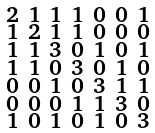<formula> <loc_0><loc_0><loc_500><loc_500>\begin{smallmatrix} 2 & 1 & 1 & 1 & 0 & 0 & 1 \\ 1 & 2 & 1 & 1 & 0 & 0 & 0 \\ 1 & 1 & 3 & 0 & 1 & 0 & 1 \\ 1 & 1 & 0 & 3 & 0 & 1 & 0 \\ 0 & 0 & 1 & 0 & 3 & 1 & 1 \\ 0 & 0 & 0 & 1 & 1 & 3 & 0 \\ 1 & 0 & 1 & 0 & 1 & 0 & 3 \end{smallmatrix}</formula> 